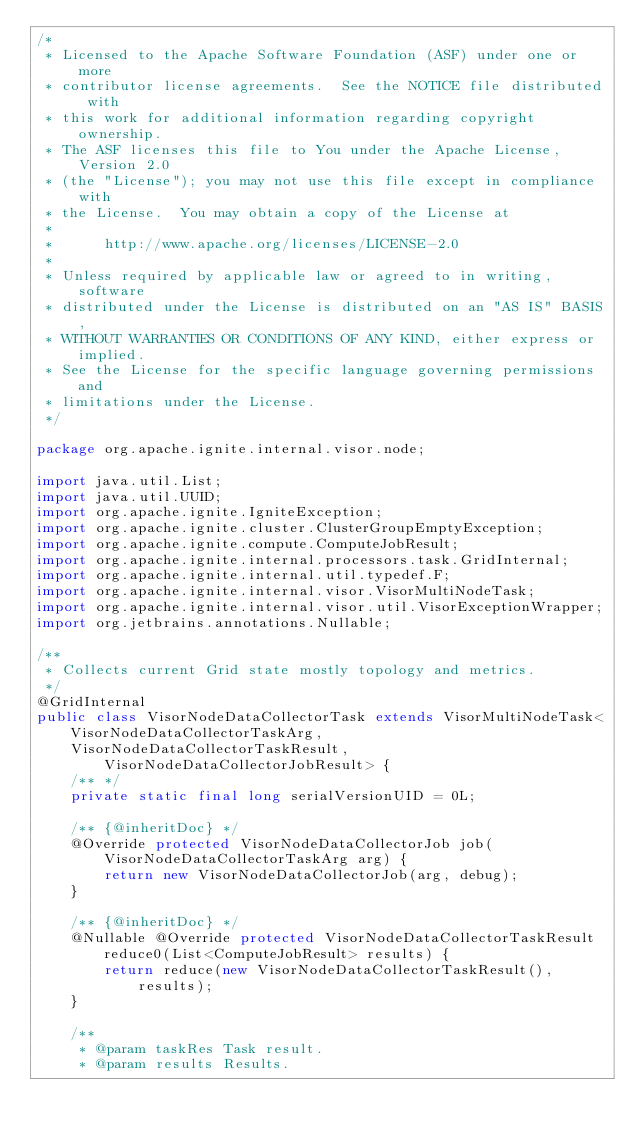<code> <loc_0><loc_0><loc_500><loc_500><_Java_>/*
 * Licensed to the Apache Software Foundation (ASF) under one or more
 * contributor license agreements.  See the NOTICE file distributed with
 * this work for additional information regarding copyright ownership.
 * The ASF licenses this file to You under the Apache License, Version 2.0
 * (the "License"); you may not use this file except in compliance with
 * the License.  You may obtain a copy of the License at
 *
 *      http://www.apache.org/licenses/LICENSE-2.0
 *
 * Unless required by applicable law or agreed to in writing, software
 * distributed under the License is distributed on an "AS IS" BASIS,
 * WITHOUT WARRANTIES OR CONDITIONS OF ANY KIND, either express or implied.
 * See the License for the specific language governing permissions and
 * limitations under the License.
 */

package org.apache.ignite.internal.visor.node;

import java.util.List;
import java.util.UUID;
import org.apache.ignite.IgniteException;
import org.apache.ignite.cluster.ClusterGroupEmptyException;
import org.apache.ignite.compute.ComputeJobResult;
import org.apache.ignite.internal.processors.task.GridInternal;
import org.apache.ignite.internal.util.typedef.F;
import org.apache.ignite.internal.visor.VisorMultiNodeTask;
import org.apache.ignite.internal.visor.util.VisorExceptionWrapper;
import org.jetbrains.annotations.Nullable;

/**
 * Collects current Grid state mostly topology and metrics.
 */
@GridInternal
public class VisorNodeDataCollectorTask extends VisorMultiNodeTask<VisorNodeDataCollectorTaskArg,
    VisorNodeDataCollectorTaskResult, VisorNodeDataCollectorJobResult> {
    /** */
    private static final long serialVersionUID = 0L;

    /** {@inheritDoc} */
    @Override protected VisorNodeDataCollectorJob job(VisorNodeDataCollectorTaskArg arg) {
        return new VisorNodeDataCollectorJob(arg, debug);
    }

    /** {@inheritDoc} */
    @Nullable @Override protected VisorNodeDataCollectorTaskResult reduce0(List<ComputeJobResult> results) {
        return reduce(new VisorNodeDataCollectorTaskResult(), results);
    }

    /**
     * @param taskRes Task result.
     * @param results Results.</code> 